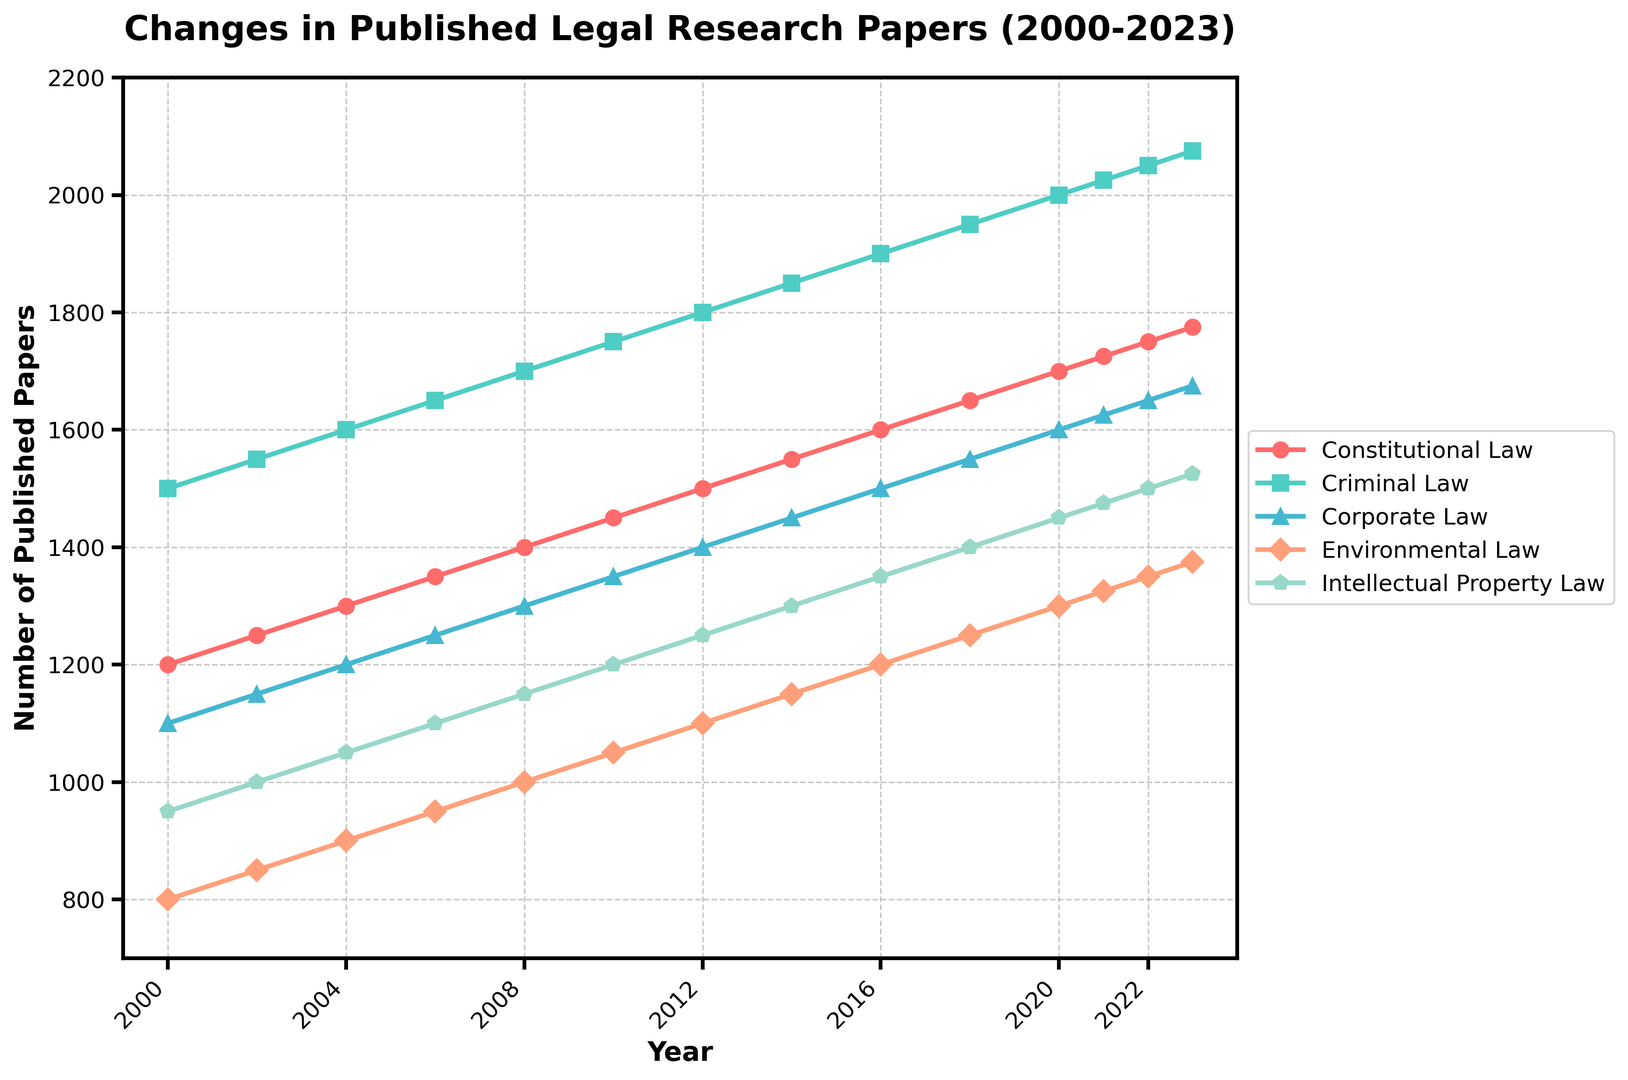What's the increase in the number of published papers in Criminal Law from 2000 to 2023? The number of published papers in Criminal Law in 2000 is 1500 and in 2023 is 2075. The increase is calculated as 2075 - 1500.
Answer: 575 Which law specialty had the highest increase in published papers from 2000 to 2023? By comparing the increase for each specialty: Constitutional Law (1775-1200 = 575), Criminal Law (2075-1500 = 575), Corporate Law (1675-1100 = 575), Environmental Law (1375-800 = 575), Intellectual Property Law (1525-950 = 575), all specialties had the same increase.
Answer: All specialties In which year did Environmental Law surpass 1000 published papers? Environmental Law reached 1000 published papers in 2008, according to the data.
Answer: 2008 Which specialty had the least number of published papers in 2008? In 2008, the number of published papers were: Constitutional Law (1400), Criminal Law (1700), Corporate Law (1300), Environmental Law (1000), Intellectual Property Law (1150). The least is Environmental Law.
Answer: Environmental Law How many more papers were published in Intellectual Property Law than in Environmental Law in 2023? Intellectual Property Law had 1525 papers in 2023, and Environmental Law had 1375 papers. The difference is calculated as 1525 - 1375.
Answer: 150 What is the average number of published papers in Criminal Law over the years 2000 to 2023? The total number of papers published in Criminal Law from 2000 to 2023 is (1500 + 1550 + 1600 + 1650 + 1700 + 1750 + 1800 + 1850 + 1900 + 1950 + 2000 + 2025 + 2050 + 2075) = 25350. Dividing this by the 14 years gives the average as 25350 / 14.
Answer: 1810.71 For which law specialty did the number of published papers stay consistently the highest from 2000 to 2023? By observing the trends, Criminal Law consistently had the highest number of published papers every year from 2000 to 2023.
Answer: Criminal Law 